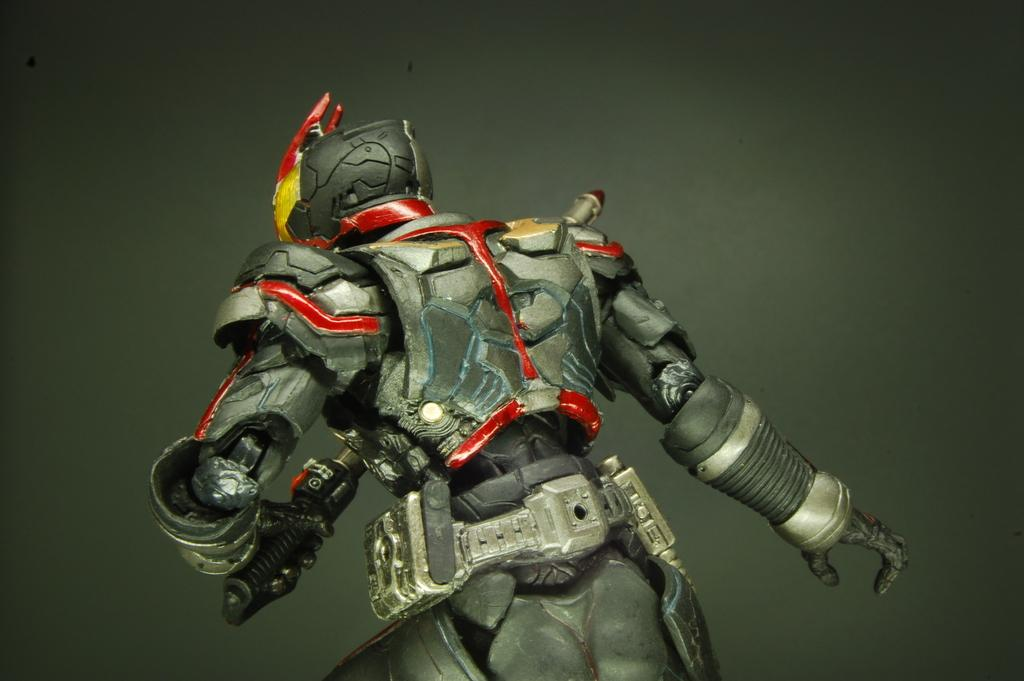What type of image is being described? The image is animated. What character or object can be seen in the image? There is a robot in the image. What color is the background of the image? The background color is grey. What type of door is visible in the image? There is no door present in the image; it is an animated image featuring a robot. What mode of transport can be seen in the image? There is no mode of transport present in the image; it features a robot and a grey background. 